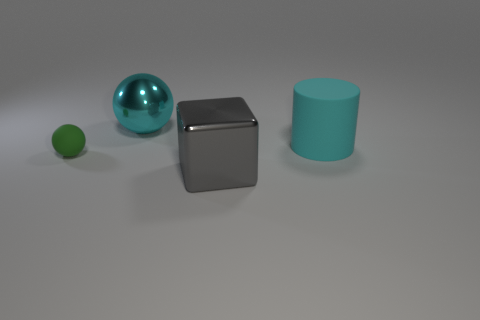Are there any small rubber balls that have the same color as the small matte object?
Offer a very short reply. No. There is a big metal thing that is on the left side of the shiny block; is its shape the same as the large cyan object that is in front of the large cyan metallic ball?
Offer a very short reply. No. There is a object that is the same color as the cylinder; what size is it?
Ensure brevity in your answer.  Large. How many other things are the same size as the cyan metallic thing?
Your answer should be very brief. 2. Does the small thing have the same color as the metallic object that is behind the gray metallic object?
Ensure brevity in your answer.  No. Are there fewer big gray metal objects behind the small green object than large cyan metallic objects on the right side of the cyan cylinder?
Your answer should be compact. No. What is the color of the large object that is both in front of the big cyan shiny ball and behind the gray block?
Your answer should be compact. Cyan. Do the gray shiny thing and the matte thing right of the tiny object have the same size?
Your answer should be compact. Yes. The large object that is in front of the small green rubber object has what shape?
Offer a very short reply. Cube. Is there anything else that has the same material as the big gray thing?
Your answer should be very brief. Yes. 